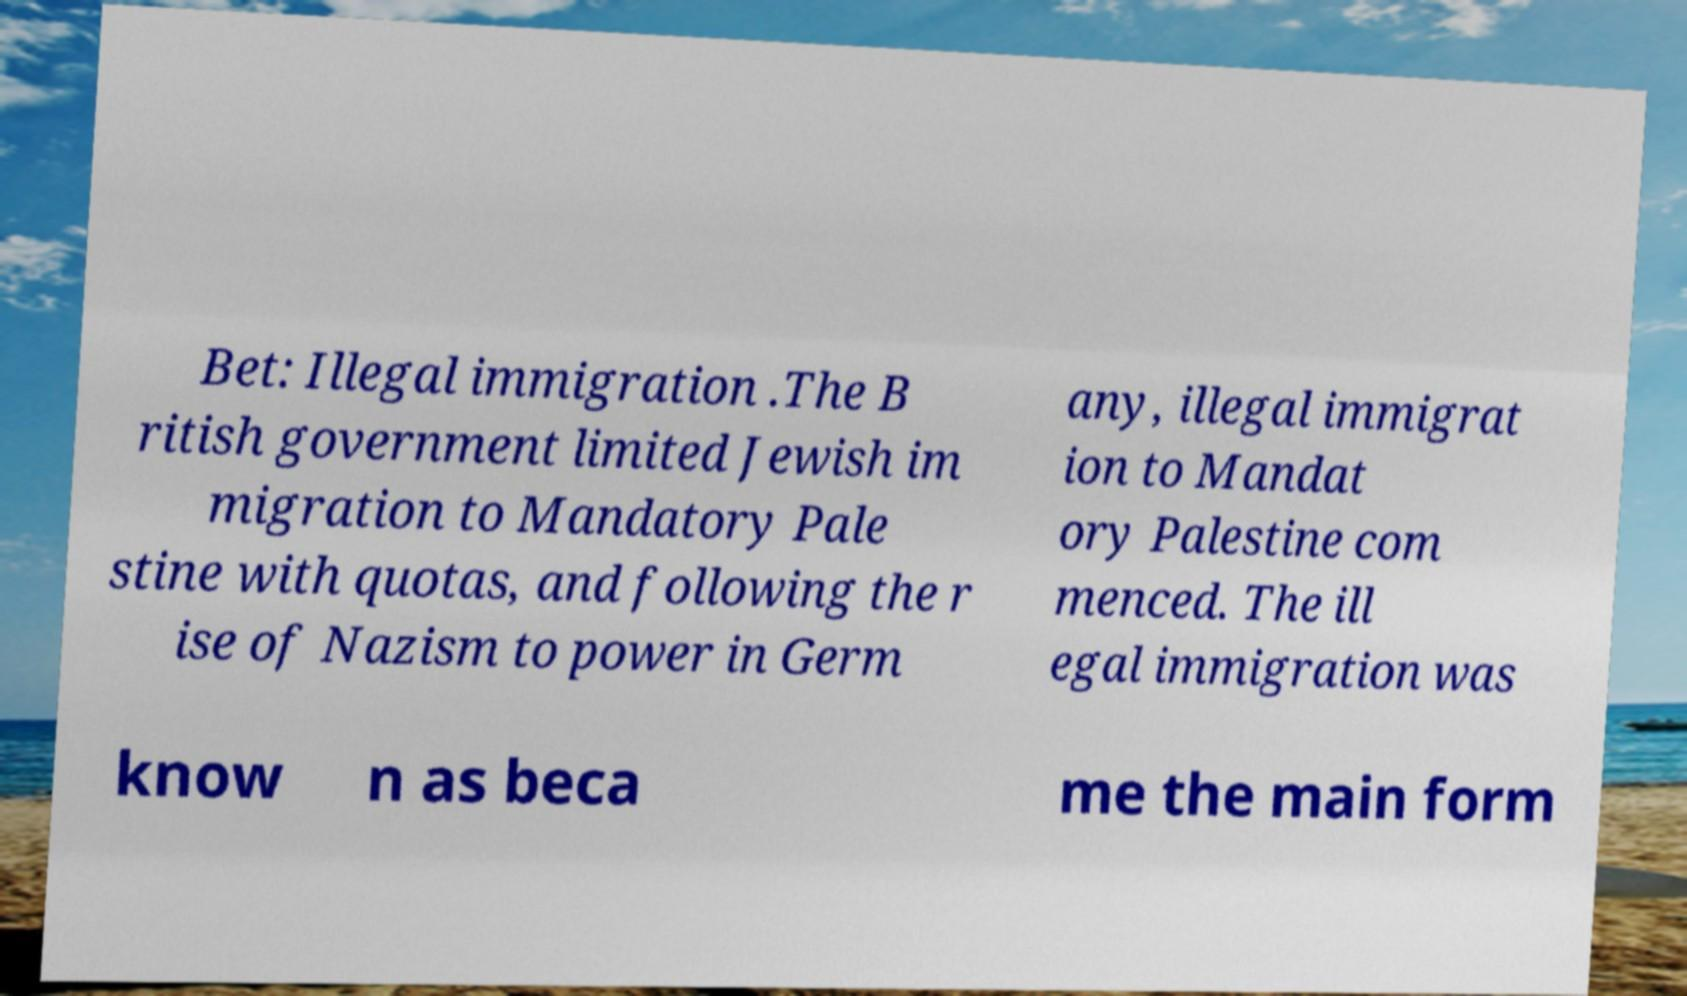Could you extract and type out the text from this image? Bet: Illegal immigration .The B ritish government limited Jewish im migration to Mandatory Pale stine with quotas, and following the r ise of Nazism to power in Germ any, illegal immigrat ion to Mandat ory Palestine com menced. The ill egal immigration was know n as beca me the main form 